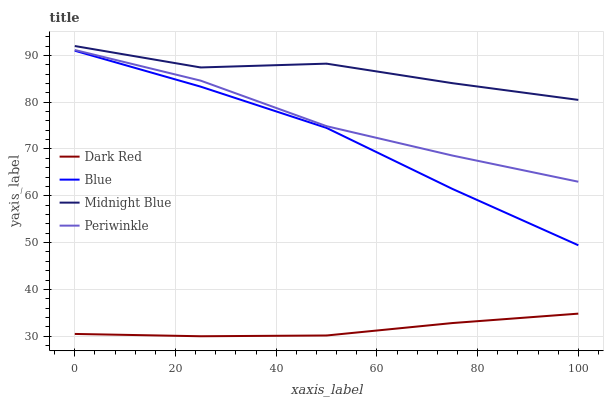Does Periwinkle have the minimum area under the curve?
Answer yes or no. No. Does Periwinkle have the maximum area under the curve?
Answer yes or no. No. Is Periwinkle the smoothest?
Answer yes or no. No. Is Periwinkle the roughest?
Answer yes or no. No. Does Periwinkle have the lowest value?
Answer yes or no. No. Does Periwinkle have the highest value?
Answer yes or no. No. Is Blue less than Midnight Blue?
Answer yes or no. Yes. Is Midnight Blue greater than Dark Red?
Answer yes or no. Yes. Does Blue intersect Midnight Blue?
Answer yes or no. No. 